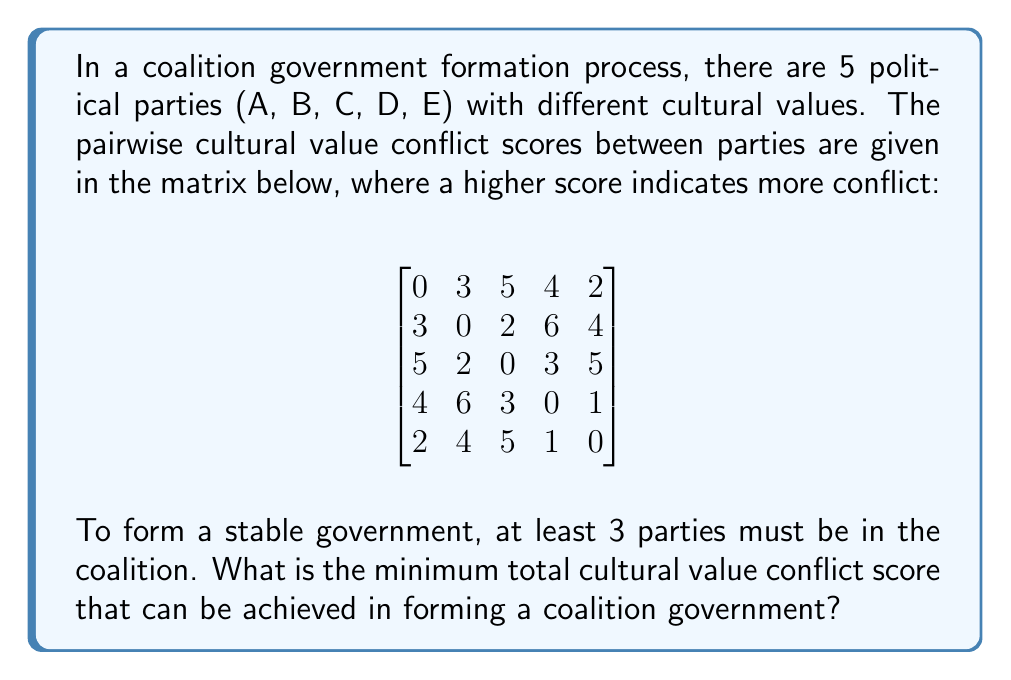Can you answer this question? To solve this optimization problem, we need to consider all possible combinations of 3, 4, or 5 parties and calculate their total conflict scores. We'll then choose the combination with the minimum score.

1. First, let's list all possible combinations:
   3-party coalitions: (A,B,C), (A,B,D), (A,B,E), (A,C,D), (A,C,E), (A,D,E), (B,C,D), (B,C,E), (B,D,E), (C,D,E)
   4-party coalitions: (A,B,C,D), (A,B,C,E), (A,B,D,E), (A,C,D,E), (B,C,D,E)
   5-party coalition: (A,B,C,D,E)

2. Now, we'll calculate the conflict score for each combination:

   For 3-party coalitions:
   (A,B,C): 3 + 5 + 2 = 10
   (A,B,D): 3 + 4 + 6 = 13
   (A,B,E): 3 + 2 + 4 = 9
   (A,C,D): 5 + 4 + 3 = 12
   (A,C,E): 5 + 2 + 5 = 12
   (A,D,E): 4 + 2 + 1 = 7
   (B,C,D): 2 + 6 + 3 = 11
   (B,C,E): 2 + 4 + 5 = 11
   (B,D,E): 6 + 4 + 1 = 11
   (C,D,E): 3 + 5 + 1 = 9

   For 4-party coalitions:
   (A,B,C,D): 3 + 5 + 4 + 2 + 6 + 3 = 23
   (A,B,C,E): 3 + 5 + 2 + 2 + 4 + 5 = 21
   (A,B,D,E): 3 + 4 + 2 + 6 + 4 + 1 = 20
   (A,C,D,E): 5 + 4 + 2 + 3 + 5 + 1 = 20
   (B,C,D,E): 2 + 6 + 4 + 3 + 5 + 1 = 21

   For 5-party coalition:
   (A,B,C,D,E): 3 + 5 + 4 + 2 + 2 + 6 + 4 + 3 + 5 + 1 = 35

3. The minimum conflict score is 7, achieved by the coalition (A,D,E).
Answer: The minimum total cultural value conflict score that can be achieved in forming a coalition government is 7, by forming a coalition of parties A, D, and E. 